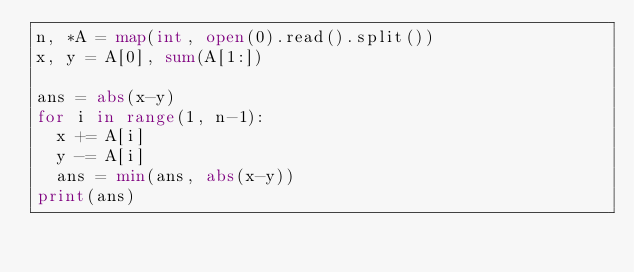Convert code to text. <code><loc_0><loc_0><loc_500><loc_500><_Python_>n, *A = map(int, open(0).read().split())
x, y = A[0], sum(A[1:])

ans = abs(x-y)
for i in range(1, n-1):
  x += A[i]
  y -= A[i]
  ans = min(ans, abs(x-y))
print(ans)</code> 